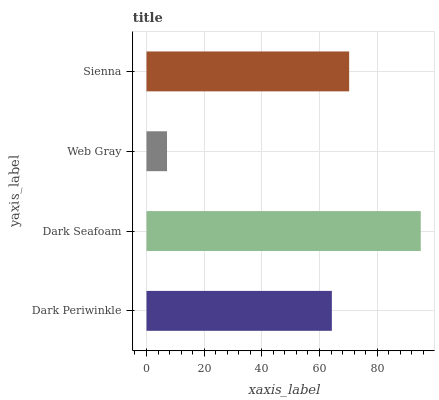Is Web Gray the minimum?
Answer yes or no. Yes. Is Dark Seafoam the maximum?
Answer yes or no. Yes. Is Dark Seafoam the minimum?
Answer yes or no. No. Is Web Gray the maximum?
Answer yes or no. No. Is Dark Seafoam greater than Web Gray?
Answer yes or no. Yes. Is Web Gray less than Dark Seafoam?
Answer yes or no. Yes. Is Web Gray greater than Dark Seafoam?
Answer yes or no. No. Is Dark Seafoam less than Web Gray?
Answer yes or no. No. Is Sienna the high median?
Answer yes or no. Yes. Is Dark Periwinkle the low median?
Answer yes or no. Yes. Is Dark Seafoam the high median?
Answer yes or no. No. Is Dark Seafoam the low median?
Answer yes or no. No. 